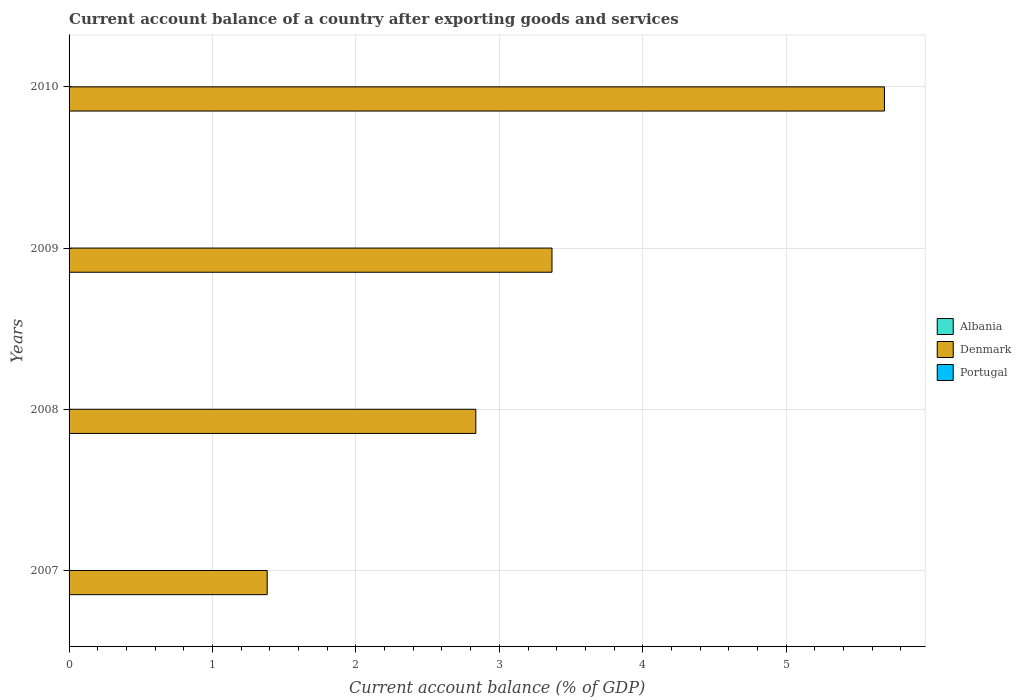How many bars are there on the 3rd tick from the top?
Offer a very short reply. 1. In how many cases, is the number of bars for a given year not equal to the number of legend labels?
Your answer should be very brief. 4. What is the account balance in Denmark in 2010?
Your answer should be very brief. 5.69. Across all years, what is the maximum account balance in Denmark?
Make the answer very short. 5.69. Across all years, what is the minimum account balance in Portugal?
Your response must be concise. 0. What is the total account balance in Denmark in the graph?
Your response must be concise. 13.27. What is the difference between the account balance in Denmark in 2008 and that in 2010?
Make the answer very short. -2.85. What is the difference between the account balance in Denmark in 2009 and the account balance in Albania in 2008?
Your response must be concise. 3.37. In how many years, is the account balance in Denmark greater than 5.6 %?
Your answer should be very brief. 1. What is the ratio of the account balance in Denmark in 2009 to that in 2010?
Offer a terse response. 0.59. What is the difference between the highest and the lowest account balance in Denmark?
Your answer should be very brief. 4.3. In how many years, is the account balance in Albania greater than the average account balance in Albania taken over all years?
Your response must be concise. 0. How many years are there in the graph?
Your answer should be very brief. 4. What is the difference between two consecutive major ticks on the X-axis?
Make the answer very short. 1. Does the graph contain grids?
Make the answer very short. Yes. Where does the legend appear in the graph?
Ensure brevity in your answer.  Center right. How many legend labels are there?
Offer a terse response. 3. What is the title of the graph?
Make the answer very short. Current account balance of a country after exporting goods and services. Does "Turkey" appear as one of the legend labels in the graph?
Your answer should be very brief. No. What is the label or title of the X-axis?
Ensure brevity in your answer.  Current account balance (% of GDP). What is the Current account balance (% of GDP) of Denmark in 2007?
Your answer should be compact. 1.38. What is the Current account balance (% of GDP) of Portugal in 2007?
Your answer should be very brief. 0. What is the Current account balance (% of GDP) in Denmark in 2008?
Give a very brief answer. 2.84. What is the Current account balance (% of GDP) of Portugal in 2008?
Give a very brief answer. 0. What is the Current account balance (% of GDP) of Denmark in 2009?
Ensure brevity in your answer.  3.37. What is the Current account balance (% of GDP) in Denmark in 2010?
Give a very brief answer. 5.69. Across all years, what is the maximum Current account balance (% of GDP) in Denmark?
Provide a short and direct response. 5.69. Across all years, what is the minimum Current account balance (% of GDP) in Denmark?
Keep it short and to the point. 1.38. What is the total Current account balance (% of GDP) of Albania in the graph?
Offer a terse response. 0. What is the total Current account balance (% of GDP) in Denmark in the graph?
Keep it short and to the point. 13.27. What is the total Current account balance (% of GDP) of Portugal in the graph?
Give a very brief answer. 0. What is the difference between the Current account balance (% of GDP) in Denmark in 2007 and that in 2008?
Make the answer very short. -1.45. What is the difference between the Current account balance (% of GDP) of Denmark in 2007 and that in 2009?
Your response must be concise. -1.99. What is the difference between the Current account balance (% of GDP) of Denmark in 2007 and that in 2010?
Keep it short and to the point. -4.3. What is the difference between the Current account balance (% of GDP) of Denmark in 2008 and that in 2009?
Offer a terse response. -0.53. What is the difference between the Current account balance (% of GDP) in Denmark in 2008 and that in 2010?
Your response must be concise. -2.85. What is the difference between the Current account balance (% of GDP) of Denmark in 2009 and that in 2010?
Your response must be concise. -2.32. What is the average Current account balance (% of GDP) of Denmark per year?
Offer a very short reply. 3.32. What is the average Current account balance (% of GDP) in Portugal per year?
Your answer should be compact. 0. What is the ratio of the Current account balance (% of GDP) in Denmark in 2007 to that in 2008?
Provide a succinct answer. 0.49. What is the ratio of the Current account balance (% of GDP) in Denmark in 2007 to that in 2009?
Offer a very short reply. 0.41. What is the ratio of the Current account balance (% of GDP) in Denmark in 2007 to that in 2010?
Keep it short and to the point. 0.24. What is the ratio of the Current account balance (% of GDP) in Denmark in 2008 to that in 2009?
Provide a short and direct response. 0.84. What is the ratio of the Current account balance (% of GDP) of Denmark in 2008 to that in 2010?
Make the answer very short. 0.5. What is the ratio of the Current account balance (% of GDP) of Denmark in 2009 to that in 2010?
Your answer should be very brief. 0.59. What is the difference between the highest and the second highest Current account balance (% of GDP) of Denmark?
Give a very brief answer. 2.32. What is the difference between the highest and the lowest Current account balance (% of GDP) of Denmark?
Your answer should be compact. 4.3. 